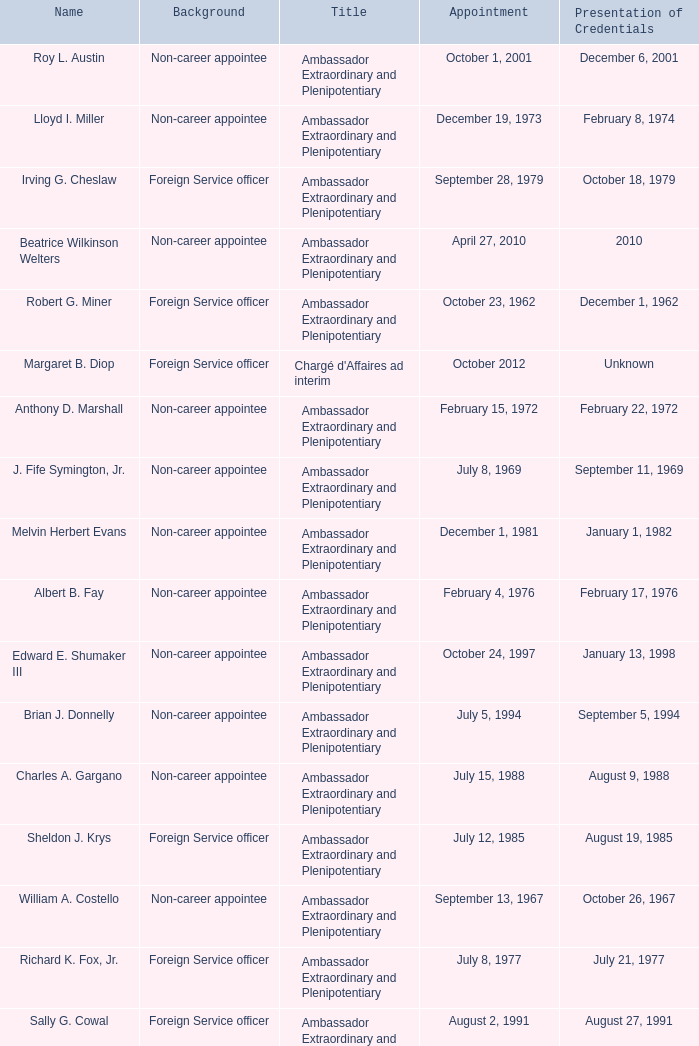When did Robert G. Miner present his credentials? December 1, 1962. 